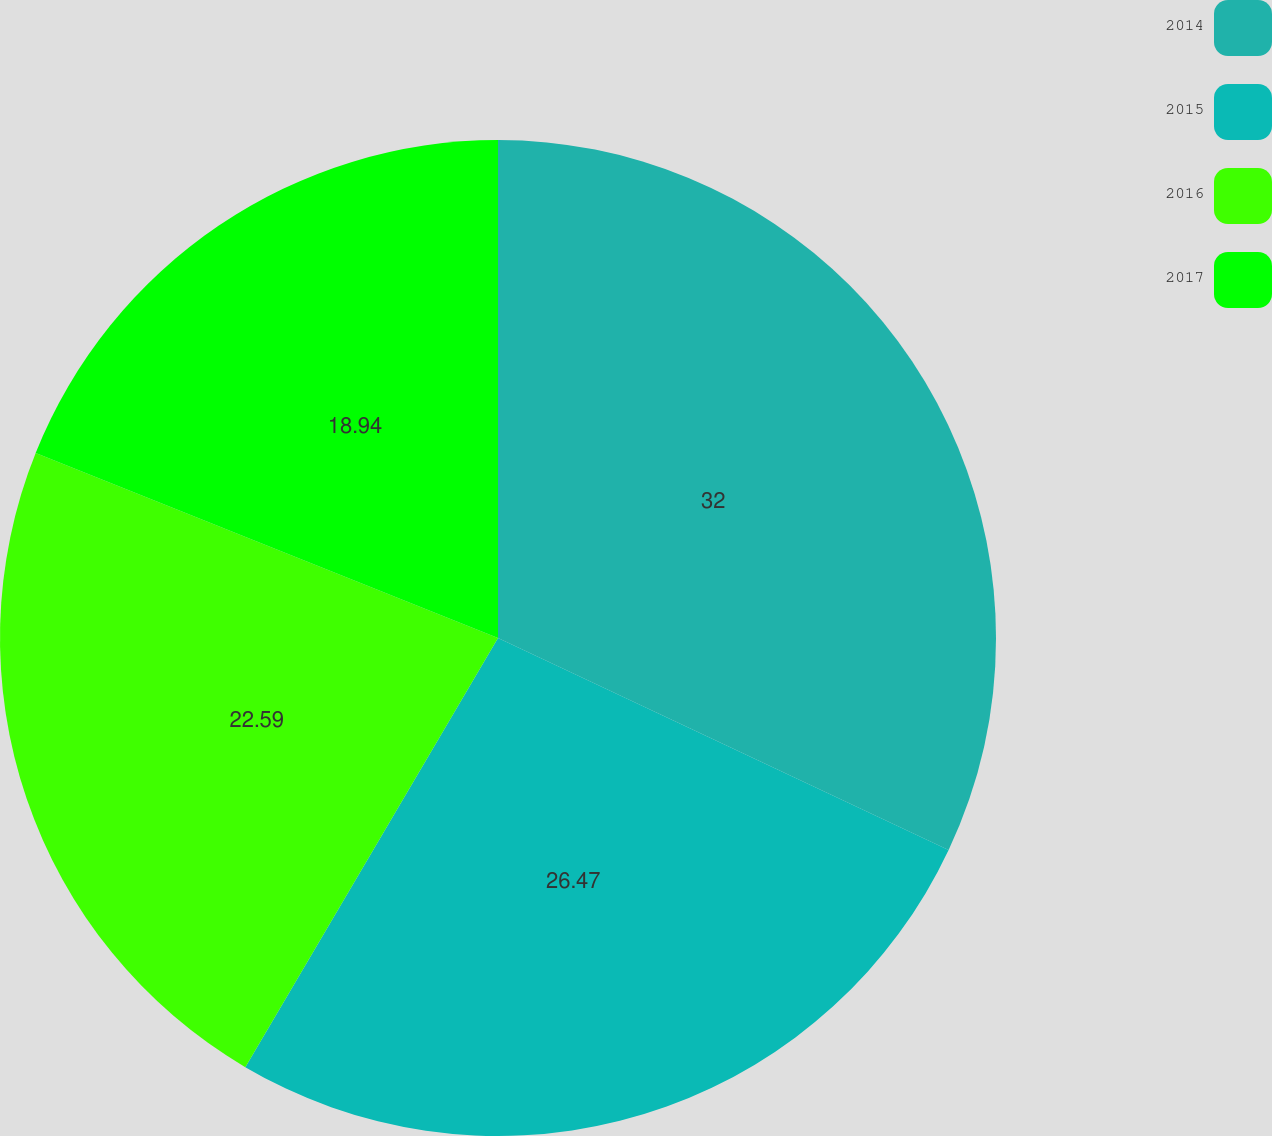Convert chart. <chart><loc_0><loc_0><loc_500><loc_500><pie_chart><fcel>2014<fcel>2015<fcel>2016<fcel>2017<nl><fcel>32.0%<fcel>26.47%<fcel>22.59%<fcel>18.94%<nl></chart> 